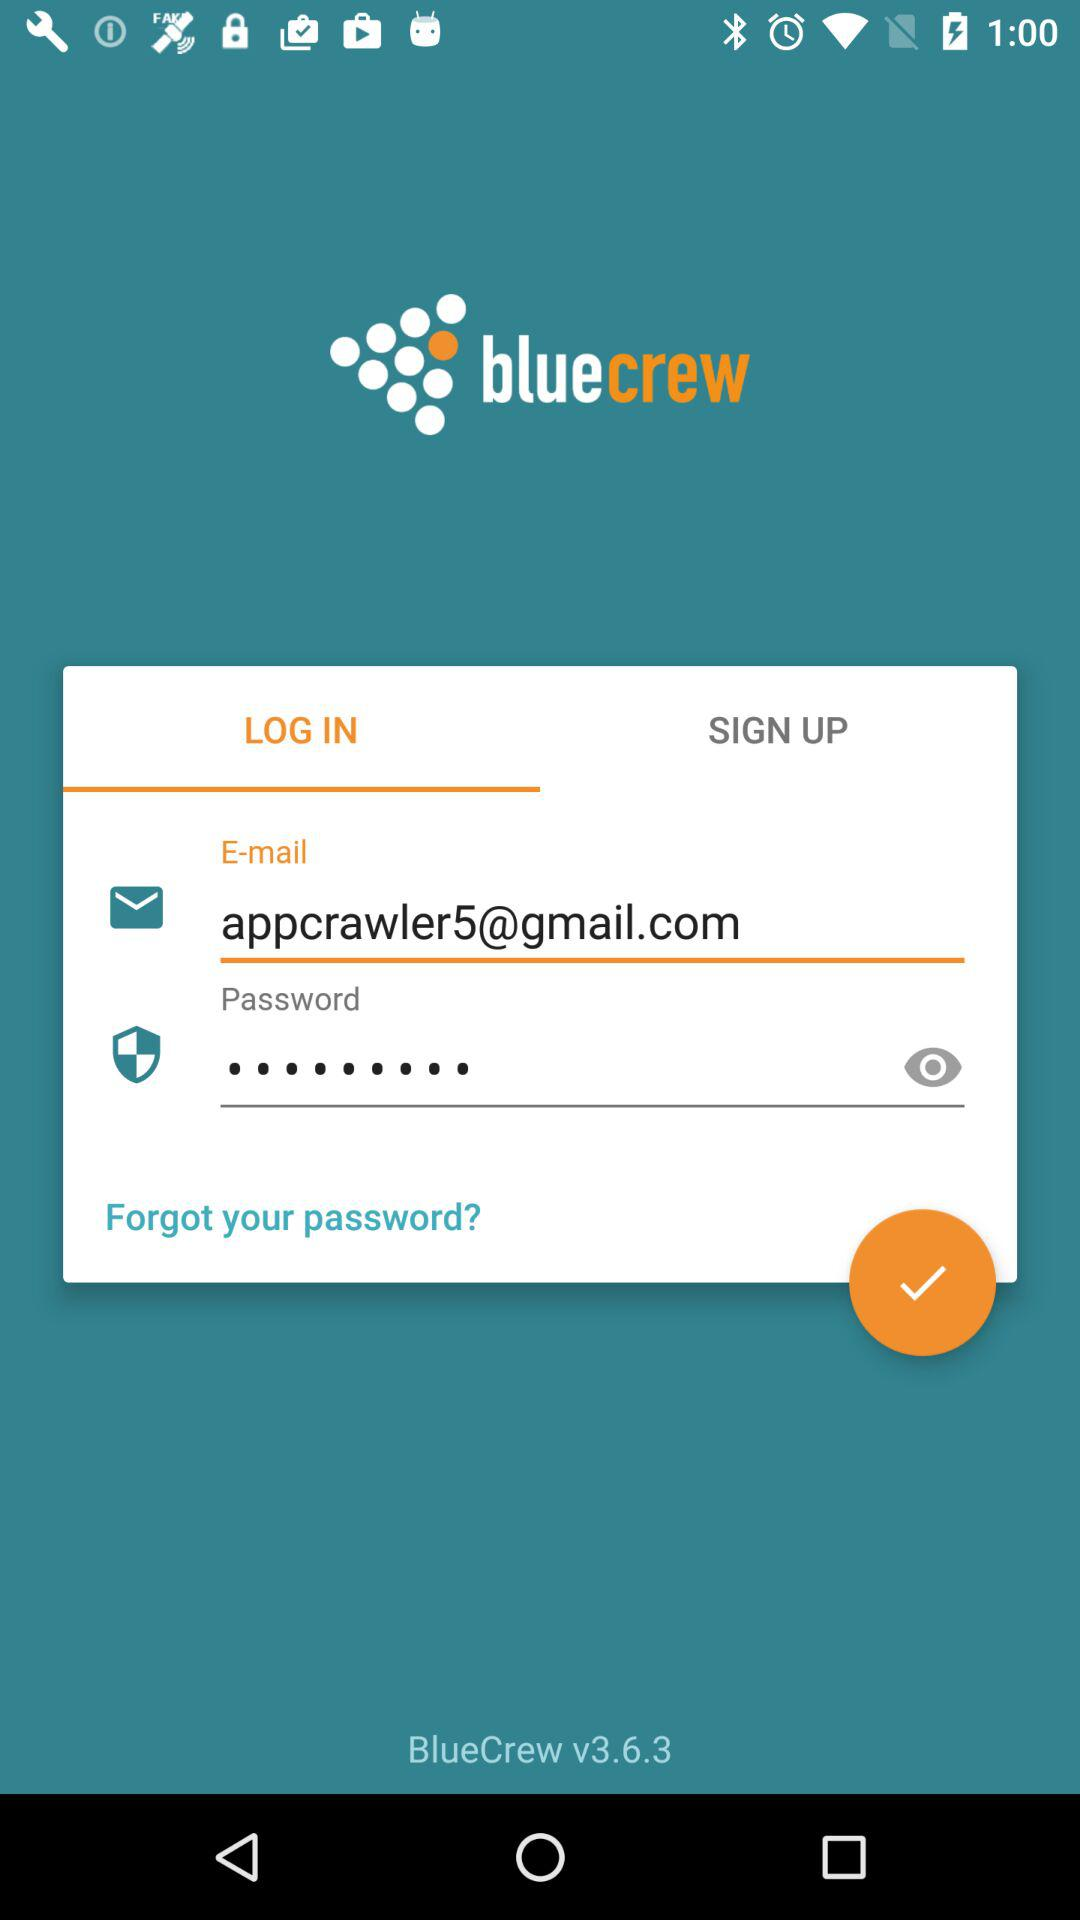Can we reset password?
When the provided information is insufficient, respond with <no answer>. <no answer> 